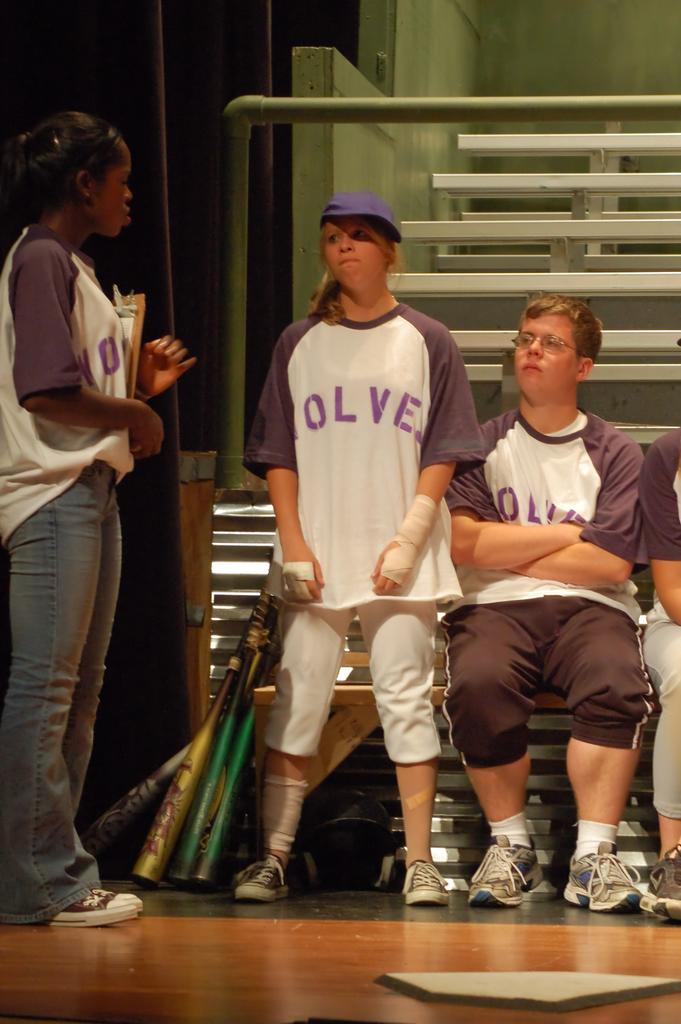What name is on the top right?
Make the answer very short. Wolves. What are the letters on their shirts?
Ensure brevity in your answer.  Olve. 